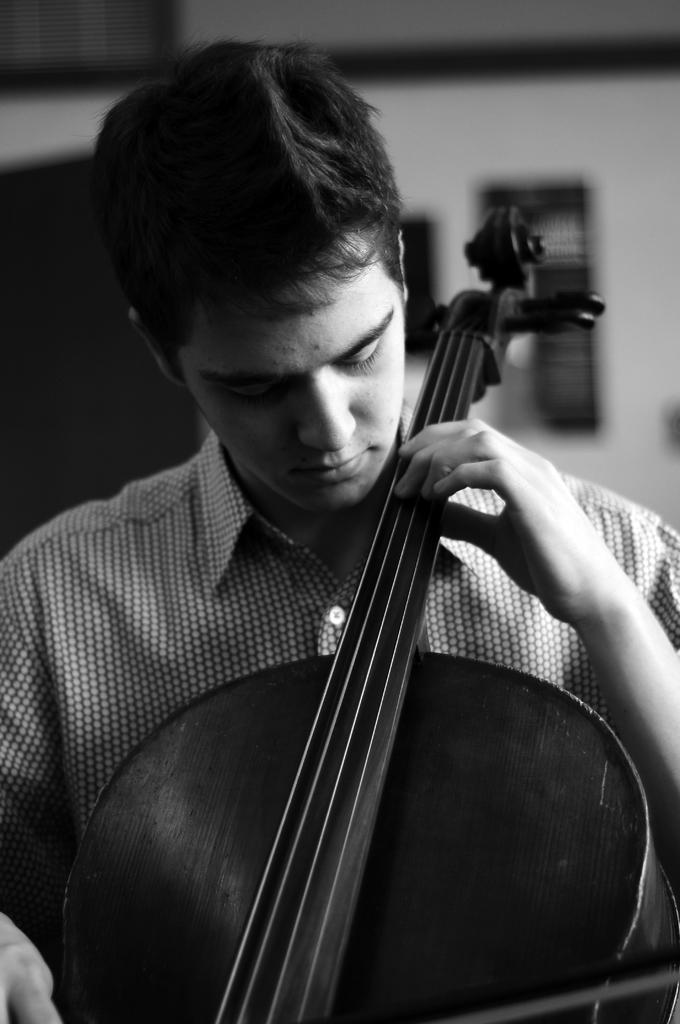What is the color scheme of the image? The image is black and white. What activity is the person in the image engaged in? The person is playing a violin in the image. Can you describe the background of the image? The background of the image is blurred. How many cents are visible in the image? There are no cents present in the image. Is there a squirrel playing the violin in the image? No, there is a person playing the violin in the image, not a squirrel. 